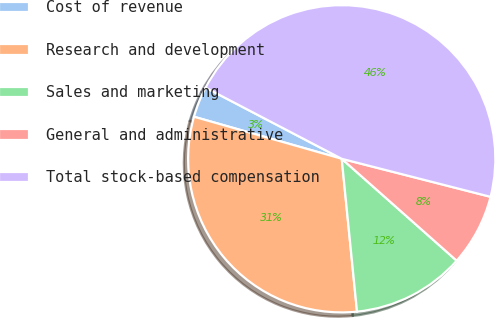Convert chart. <chart><loc_0><loc_0><loc_500><loc_500><pie_chart><fcel>Cost of revenue<fcel>Research and development<fcel>Sales and marketing<fcel>General and administrative<fcel>Total stock-based compensation<nl><fcel>3.25%<fcel>31.0%<fcel>11.87%<fcel>7.56%<fcel>46.32%<nl></chart> 